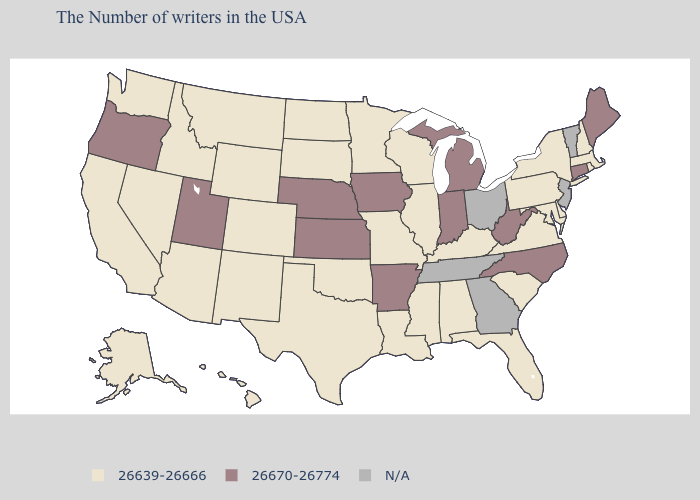Among the states that border Massachusetts , does Connecticut have the highest value?
Be succinct. Yes. What is the value of Pennsylvania?
Give a very brief answer. 26639-26666. Does Michigan have the highest value in the USA?
Be succinct. Yes. Does the first symbol in the legend represent the smallest category?
Answer briefly. Yes. What is the highest value in states that border North Carolina?
Keep it brief. 26639-26666. What is the lowest value in states that border Colorado?
Answer briefly. 26639-26666. What is the highest value in the USA?
Keep it brief. 26670-26774. What is the value of Tennessee?
Short answer required. N/A. Does Utah have the lowest value in the West?
Short answer required. No. How many symbols are there in the legend?
Quick response, please. 3. What is the value of Tennessee?
Write a very short answer. N/A. 